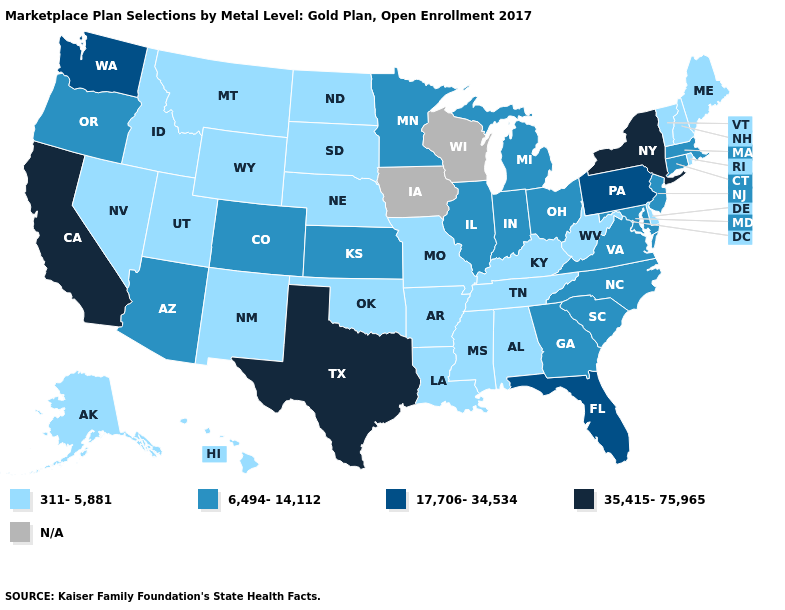Does New Jersey have the lowest value in the USA?
Be succinct. No. What is the highest value in the USA?
Write a very short answer. 35,415-75,965. Does Kansas have the lowest value in the USA?
Write a very short answer. No. What is the value of Maryland?
Write a very short answer. 6,494-14,112. Does the first symbol in the legend represent the smallest category?
Short answer required. Yes. Does California have the highest value in the USA?
Concise answer only. Yes. Does Kansas have the lowest value in the USA?
Give a very brief answer. No. What is the value of Montana?
Keep it brief. 311-5,881. What is the value of Washington?
Be succinct. 17,706-34,534. What is the lowest value in the USA?
Answer briefly. 311-5,881. How many symbols are there in the legend?
Answer briefly. 5. What is the lowest value in the MidWest?
Concise answer only. 311-5,881. What is the value of Ohio?
Keep it brief. 6,494-14,112. 